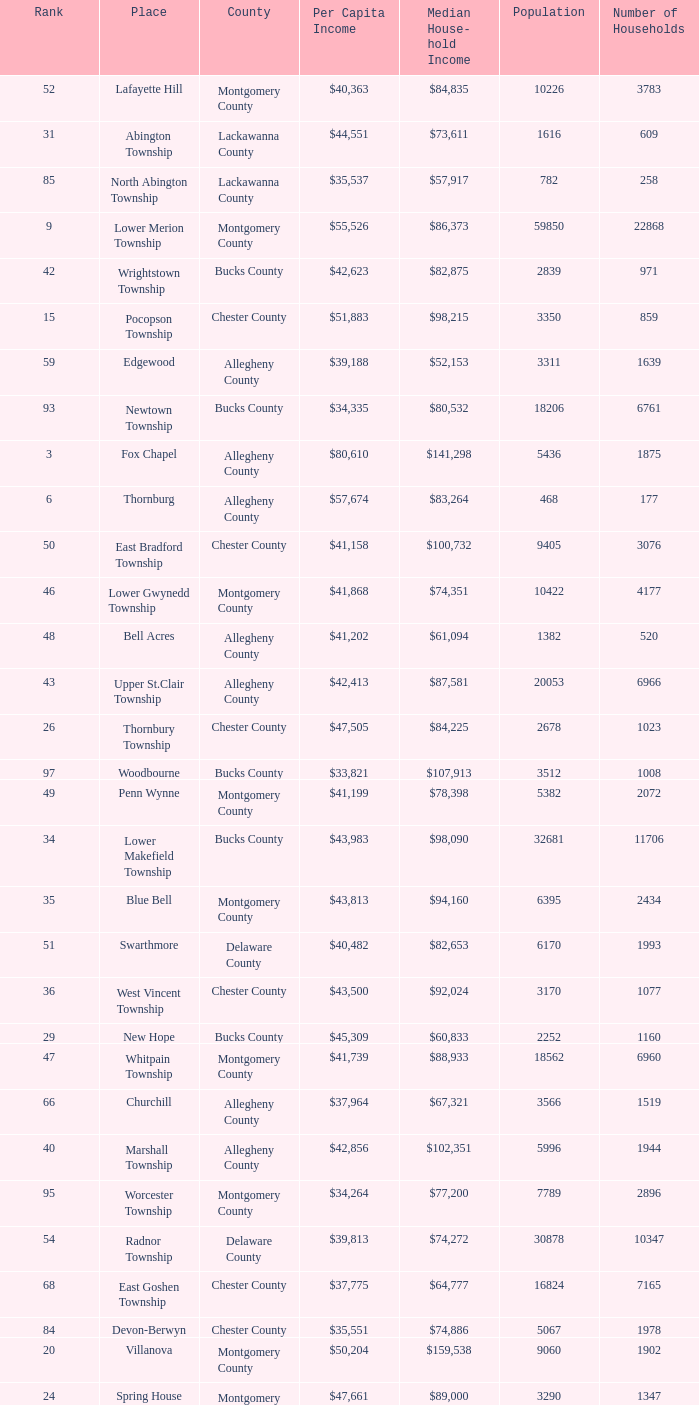What is the median household income for Woodside? $121,151. 